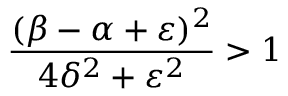<formula> <loc_0><loc_0><loc_500><loc_500>\frac { ( \beta - \alpha + \varepsilon ) ^ { 2 } } { 4 \delta ^ { 2 } + \varepsilon ^ { 2 } } > 1</formula> 